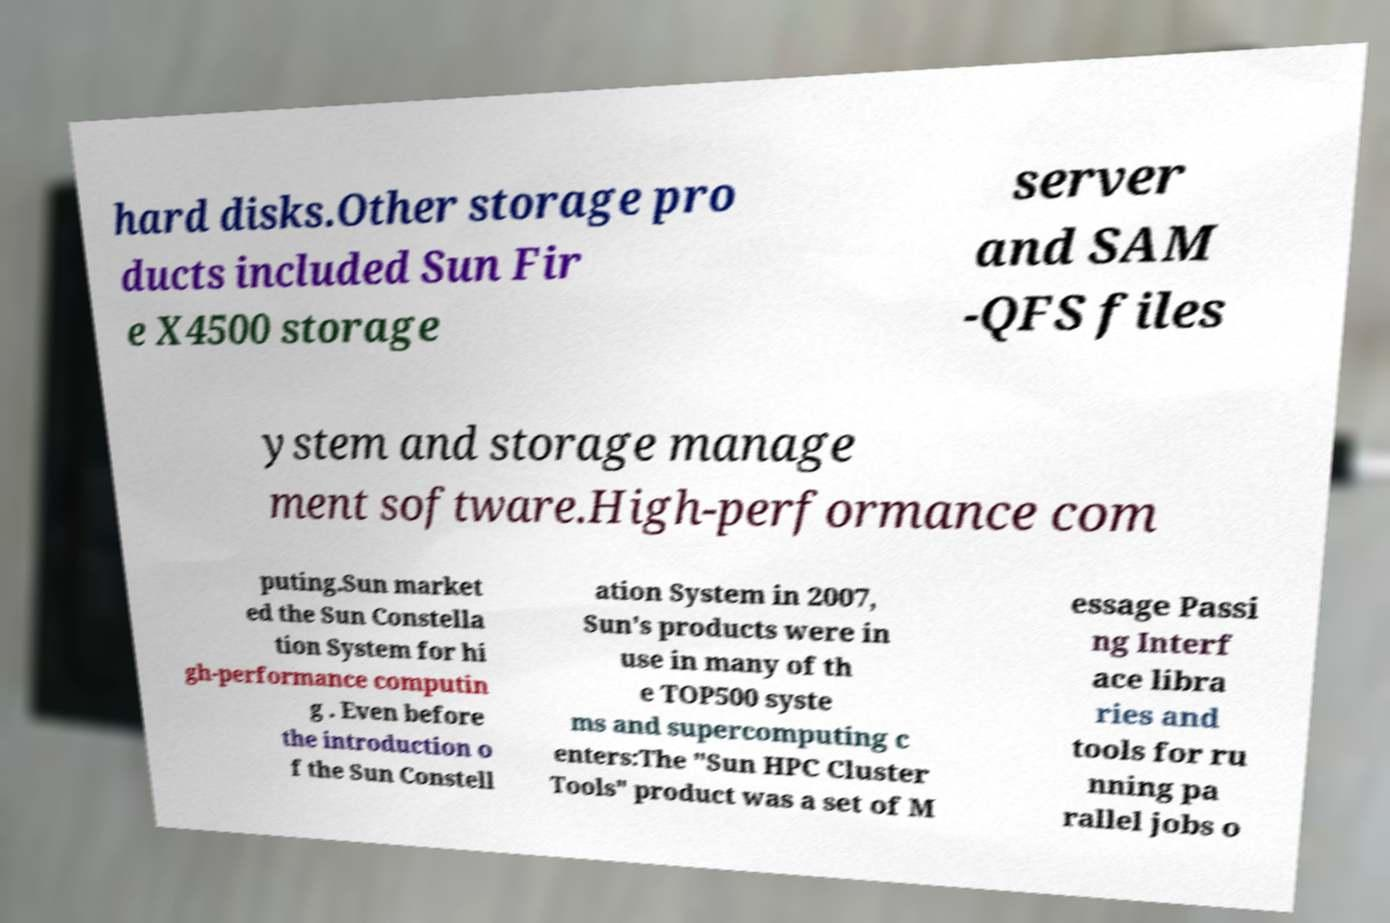What messages or text are displayed in this image? I need them in a readable, typed format. hard disks.Other storage pro ducts included Sun Fir e X4500 storage server and SAM -QFS files ystem and storage manage ment software.High-performance com puting.Sun market ed the Sun Constella tion System for hi gh-performance computin g . Even before the introduction o f the Sun Constell ation System in 2007, Sun's products were in use in many of th e TOP500 syste ms and supercomputing c enters:The "Sun HPC Cluster Tools" product was a set of M essage Passi ng Interf ace libra ries and tools for ru nning pa rallel jobs o 